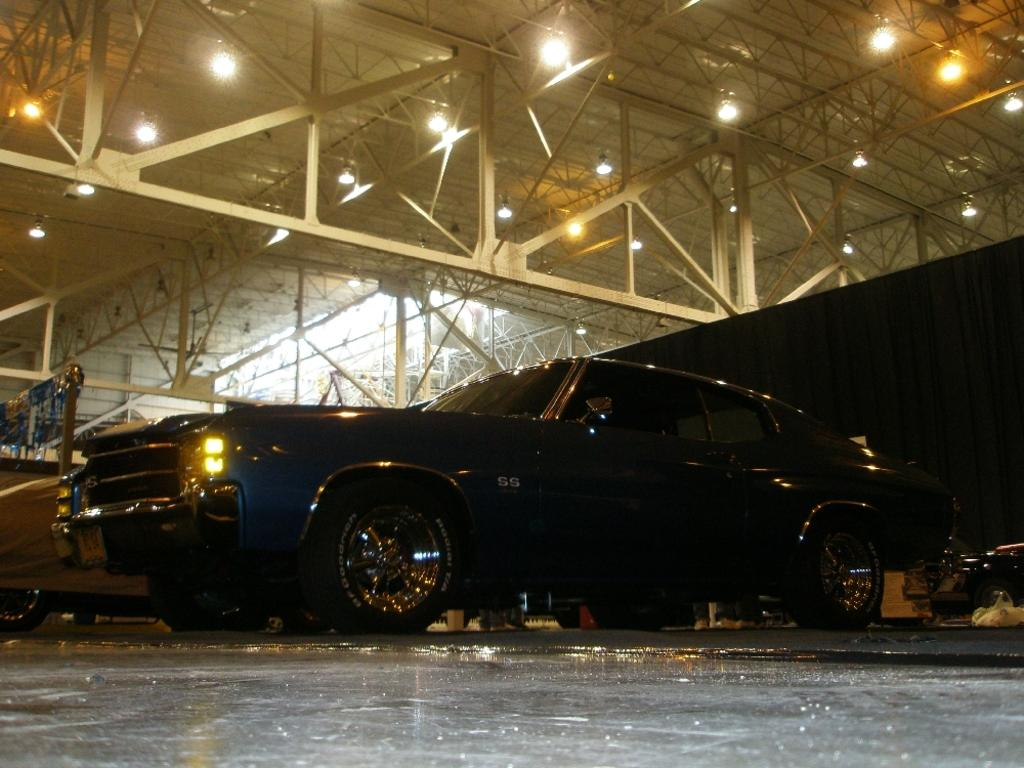What type of vehicles are inside the garage in the image? There are cars in the garage. Are there any additional features visible on the garage? Yes, there are iron rods on the roof of the garage. What type of beetle can be seen crawling on the roof of the garage in the image? There is no beetle visible on the roof of the garage in the image. How old is the daughter of the person who owns the garage in the image? There is no information about a daughter or the owner of the garage in the image. 